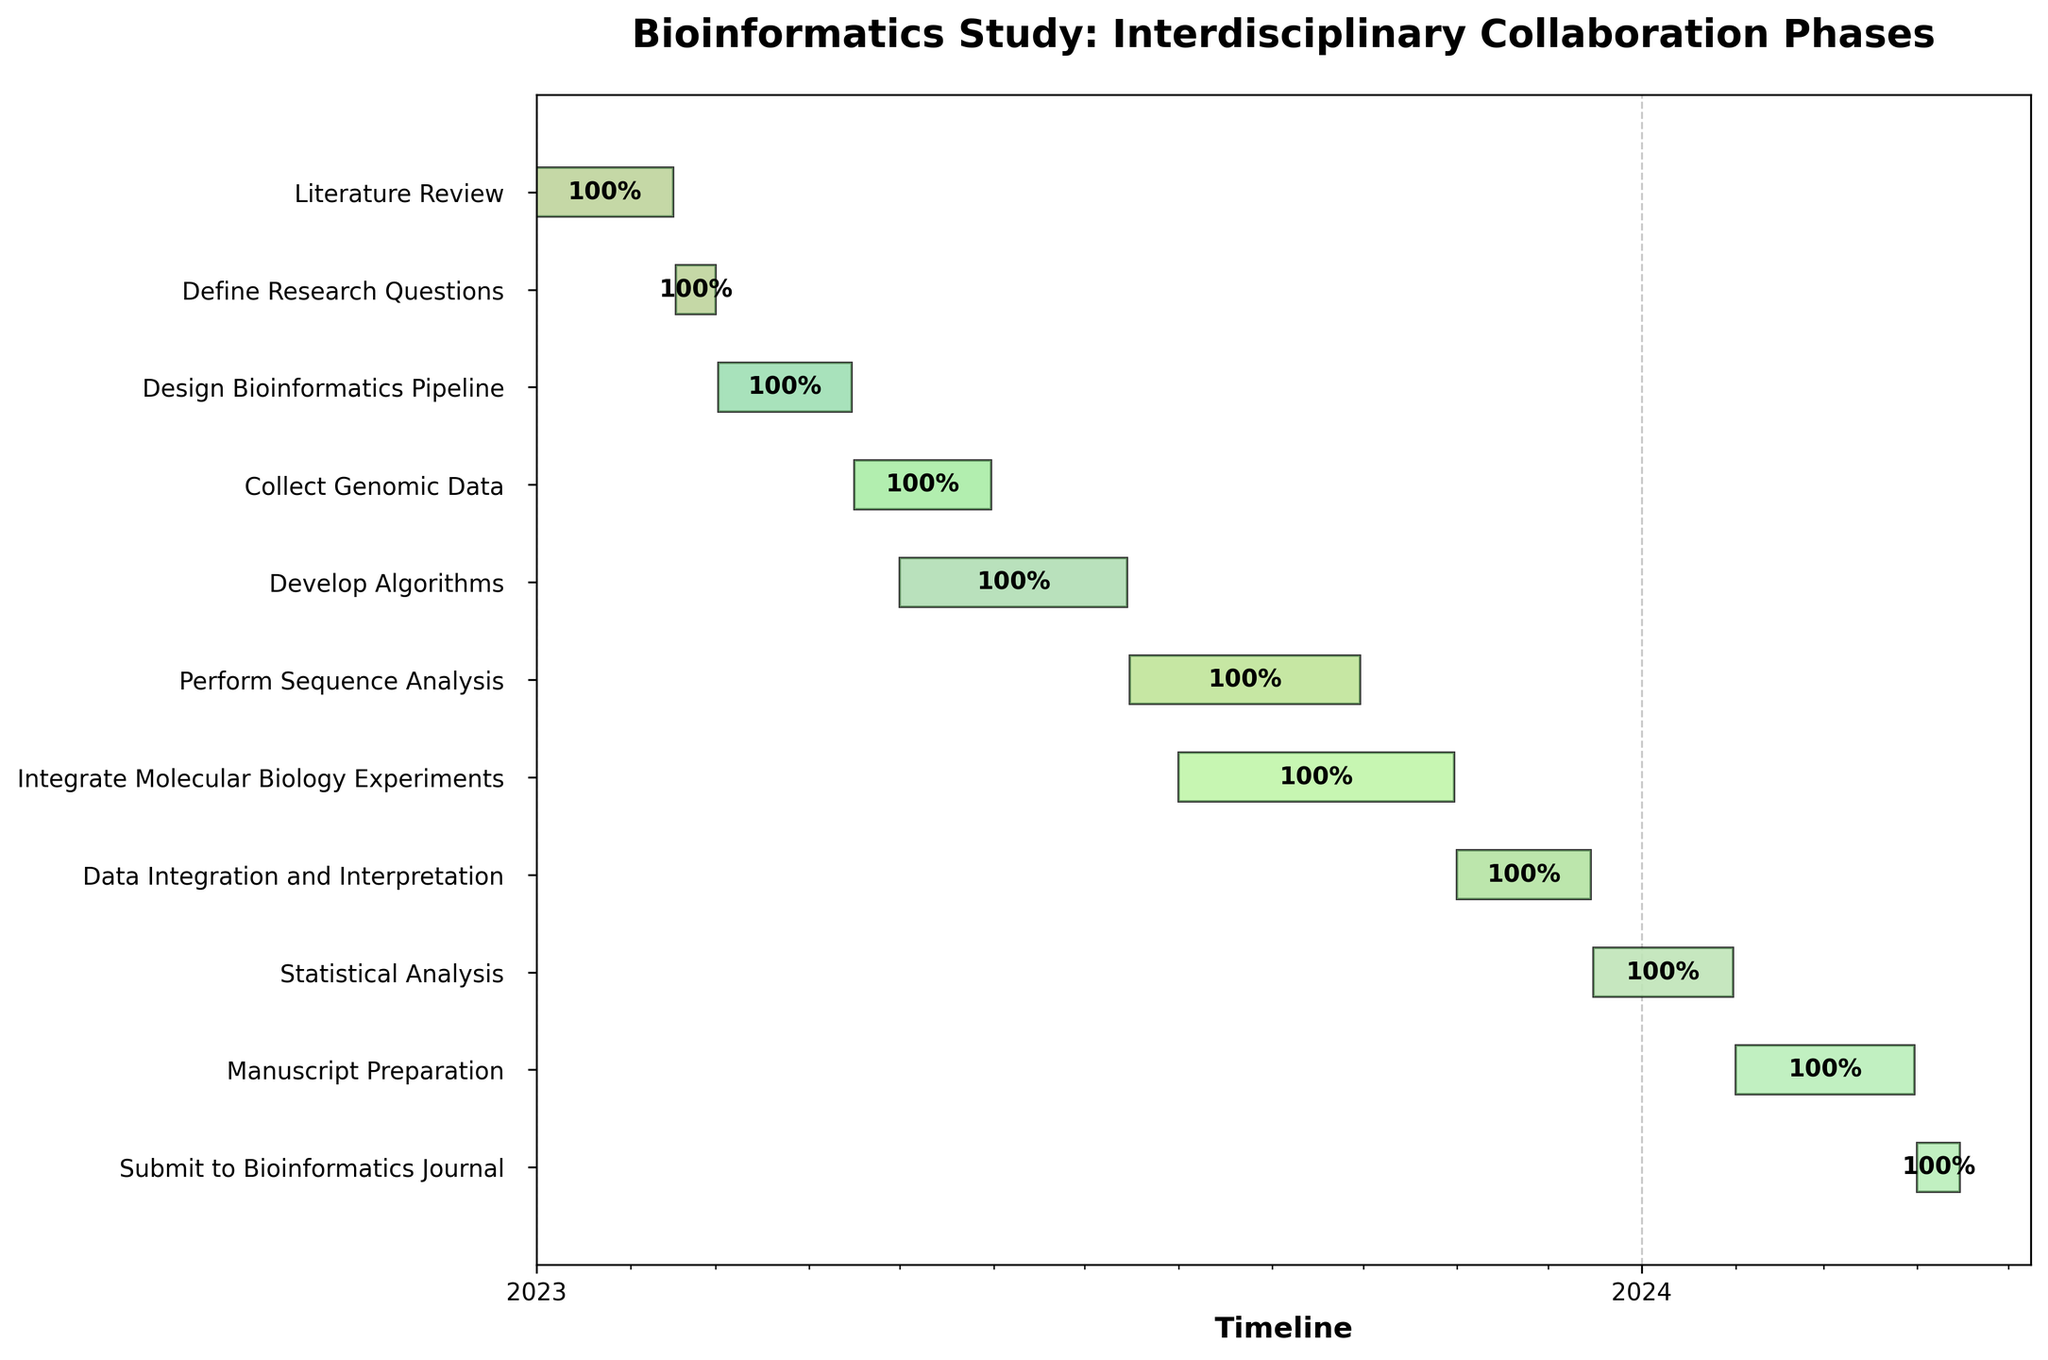What is the title of the chart? The title of the chart is usually located at the top center. In this figure, it reads "Bioinformatics Study: Interdisciplinary Collaboration Phases."
Answer: Bioinformatics Study: Interdisciplinary Collaboration Phases What is the timeline range displayed on the x-axis? The x-axis typically represents the timeline and, in this chart, it spans from January 2023 to April 2024, as indicated by the starting and ending points of the tasks.
Answer: January 2023 to April 2024 Which task has the longest duration? By inspecting the bars, we can see that the "Perform Sequence Analysis" task, extending from July 16, 2023, to September 30, 2023, has the longest duration.
Answer: Perform Sequence Analysis When does the task "Develop Algorithms" end? The end date for each task is labeled at the far right of each bar. The "Develop Algorithms" task ends on July 15, 2023.
Answer: July 15, 2023 How many tasks overlap with "Integrate Molecular Biology Experiments"? "Integrate Molecular Biology Experiments" spans from August 1, 2023, to October 31, 2023. Overlapping tasks are those that occur within this period. These include "Perform Sequence Analysis" and "Data Integration and Interpretation."
Answer: 2 Calculate the total duration of the project in days. The total duration is calculated from the start of the first task, January 1, 2023, to the end of the last task, April 15, 2024. The difference in days is 470.
Answer: 470 days Which tasks are scheduled to be completed in 2023? Tasks completed in 2023 are those whose end dates fall within that year. These tasks are "Literature Review," "Define Research Questions," "Design Bioinformatics Pipeline," "Collect Genomic Data," "Develop Algorithms," "Perform Sequence Analysis," and "Integrate Molecular Biology Experiments."
Answer: 7 tasks What is the color scheme used for the bars, and what does it signify? The bars use different shades from the "Pastel1" color palette, with progressive colors representing different tasks. It helps to visually differentiate tasks.
Answer: Pastel1 color palette (signifies task differentiation) Compare the duration of "Data Integration and Interpretation" with "Statistical Analysis." Which one is longer, and by how many days? "Data Integration and Interpretation" runs from November 1, 2023, to December 15, 2023 (45 days). "Statistical Analysis" runs from December 16, 2023, to January 31, 2024 (47 days). So, "Statistical Analysis" is 2 days longer.
Answer: Statistical Analysis, 2 days Are there any tasks that start and end within the same month? If so, which ones? Tasks that start and end within the same month would have their start and end dates in the same calendar month. None of the tasks fit this criteria.
Answer: None 